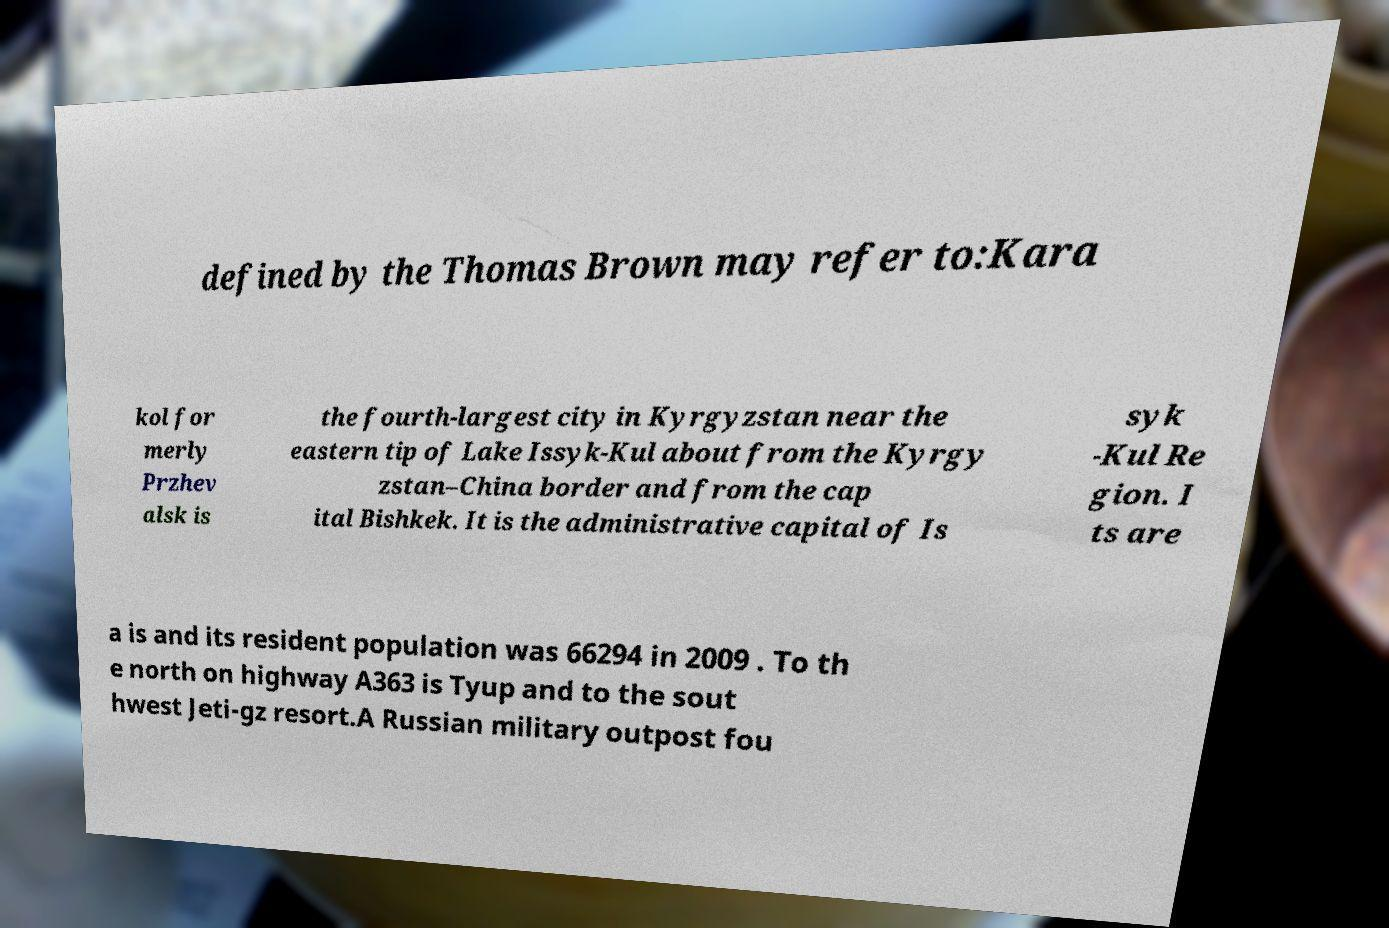Could you extract and type out the text from this image? defined by the Thomas Brown may refer to:Kara kol for merly Przhev alsk is the fourth-largest city in Kyrgyzstan near the eastern tip of Lake Issyk-Kul about from the Kyrgy zstan–China border and from the cap ital Bishkek. It is the administrative capital of Is syk -Kul Re gion. I ts are a is and its resident population was 66294 in 2009 . To th e north on highway A363 is Tyup and to the sout hwest Jeti-gz resort.A Russian military outpost fou 